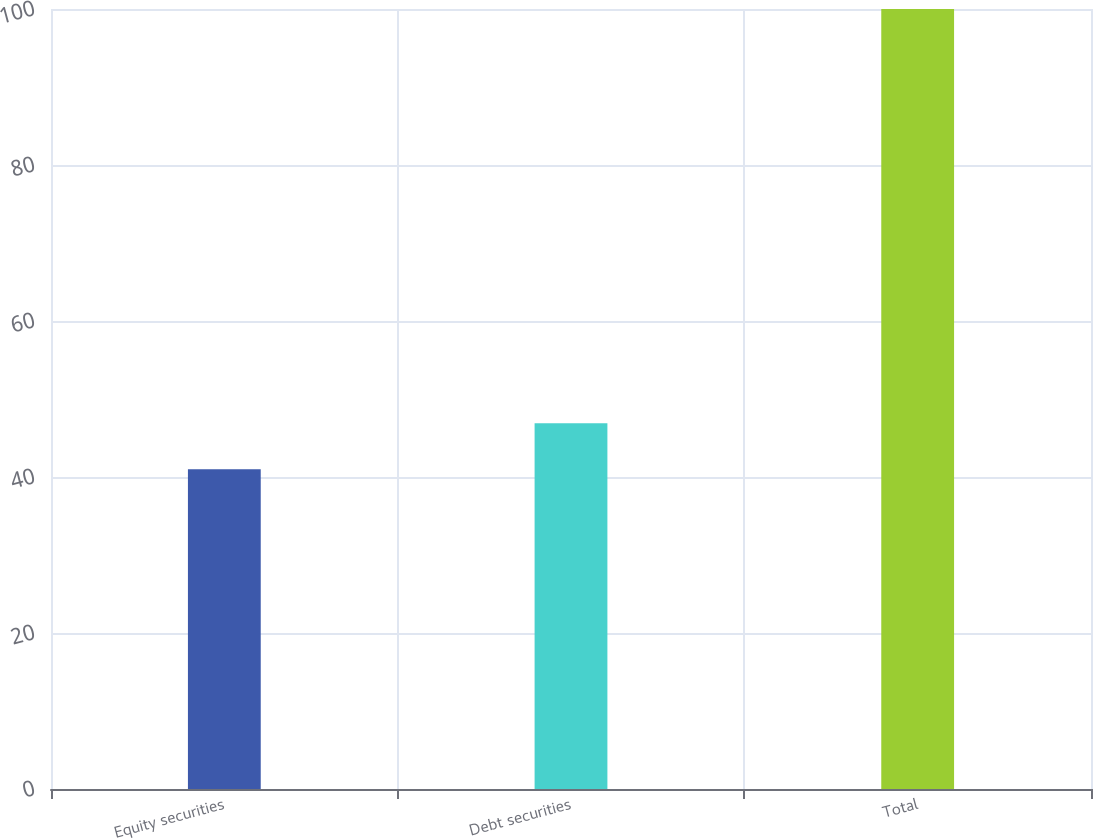Convert chart to OTSL. <chart><loc_0><loc_0><loc_500><loc_500><bar_chart><fcel>Equity securities<fcel>Debt securities<fcel>Total<nl><fcel>41<fcel>46.9<fcel>100<nl></chart> 